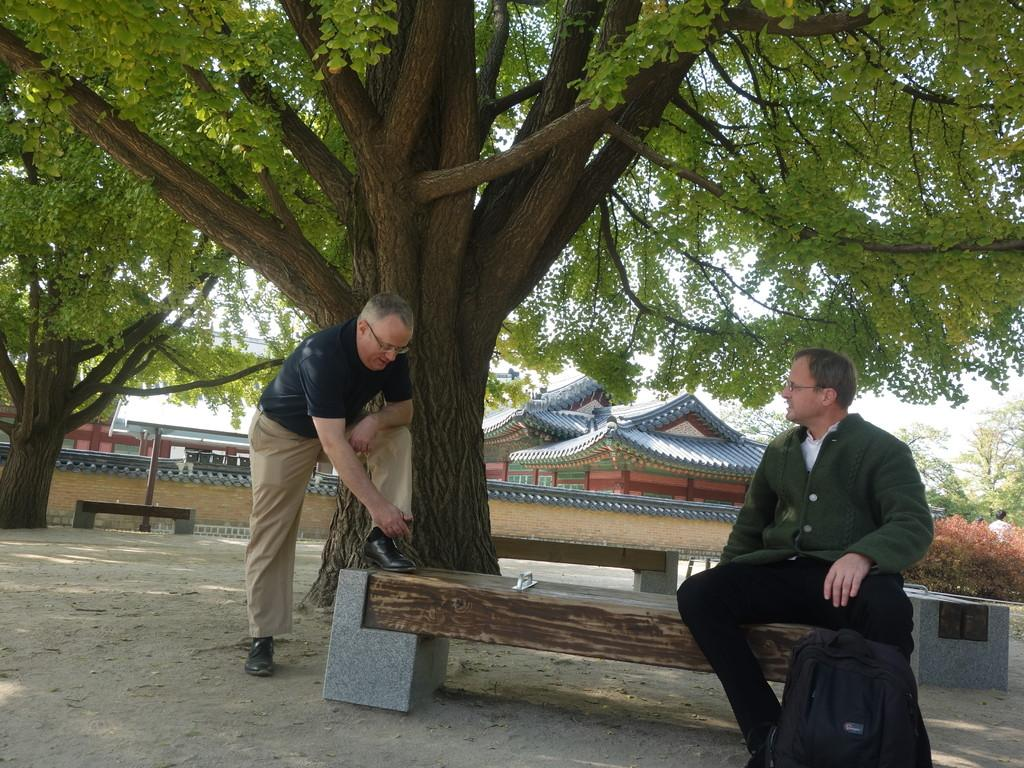What is the position of the person sitting in the image? The person sitting is on the right side of the image. What is the standing person doing near the bench? The standing person has one leg on the bench. Where is the standing person located in the image? The standing person is on the left side of the image. What can be seen in the background of the image? There are trees and buildings in the background of the image. What type of cart is the carpenter using to transport wood in the image? There is no cart or carpenter present in the image. What kind of shop can be seen in the background of the image? There is no shop visible in the background of the image. 